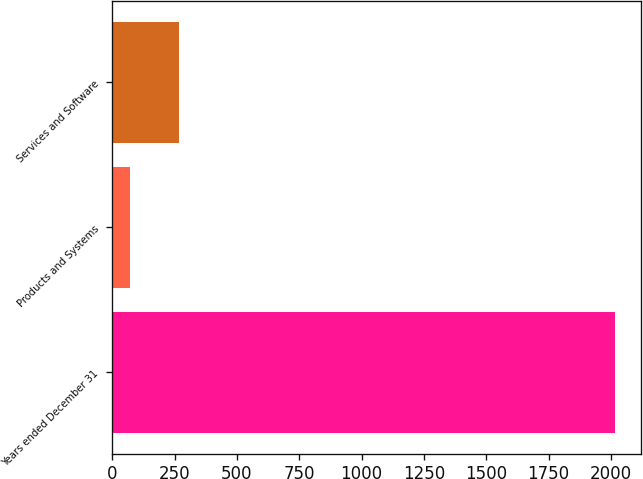Convert chart to OTSL. <chart><loc_0><loc_0><loc_500><loc_500><bar_chart><fcel>Years ended December 31<fcel>Products and Systems<fcel>Services and Software<nl><fcel>2018<fcel>72<fcel>266.6<nl></chart> 